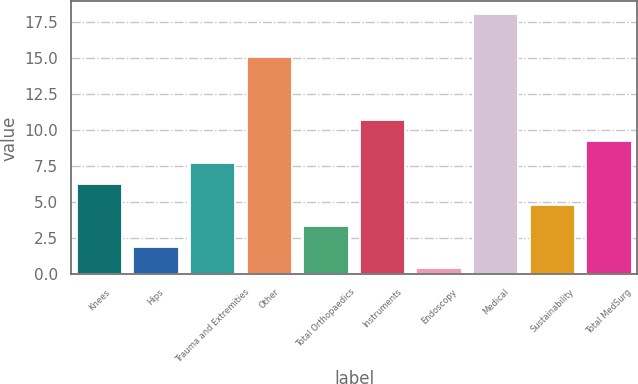Convert chart. <chart><loc_0><loc_0><loc_500><loc_500><bar_chart><fcel>Knees<fcel>Hips<fcel>Trauma and Extremities<fcel>Other<fcel>Total Orthopaedics<fcel>Instruments<fcel>Endoscopy<fcel>Medical<fcel>Sustainability<fcel>Total MedSurg<nl><fcel>6.28<fcel>1.87<fcel>7.75<fcel>15.1<fcel>3.34<fcel>10.69<fcel>0.4<fcel>18.04<fcel>4.81<fcel>9.22<nl></chart> 